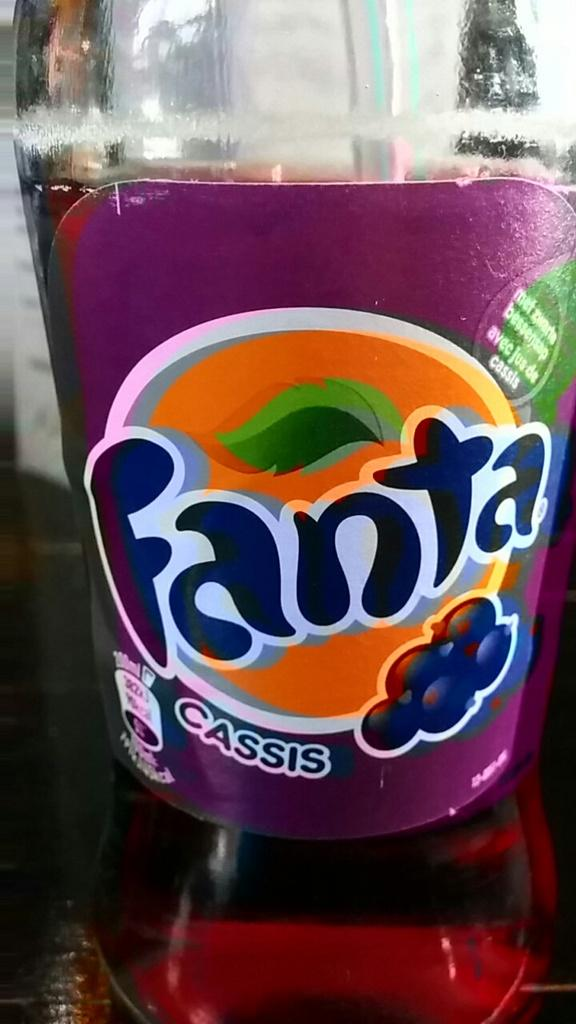What object is present in the image? There is a bottle in the image. What type of teaching method is being demonstrated with the bottle in the image? There is no teaching method being demonstrated in the image; it only features a bottle. What color is the marble inside the bottle in the image? There is no marble present inside the bottle in the image. 